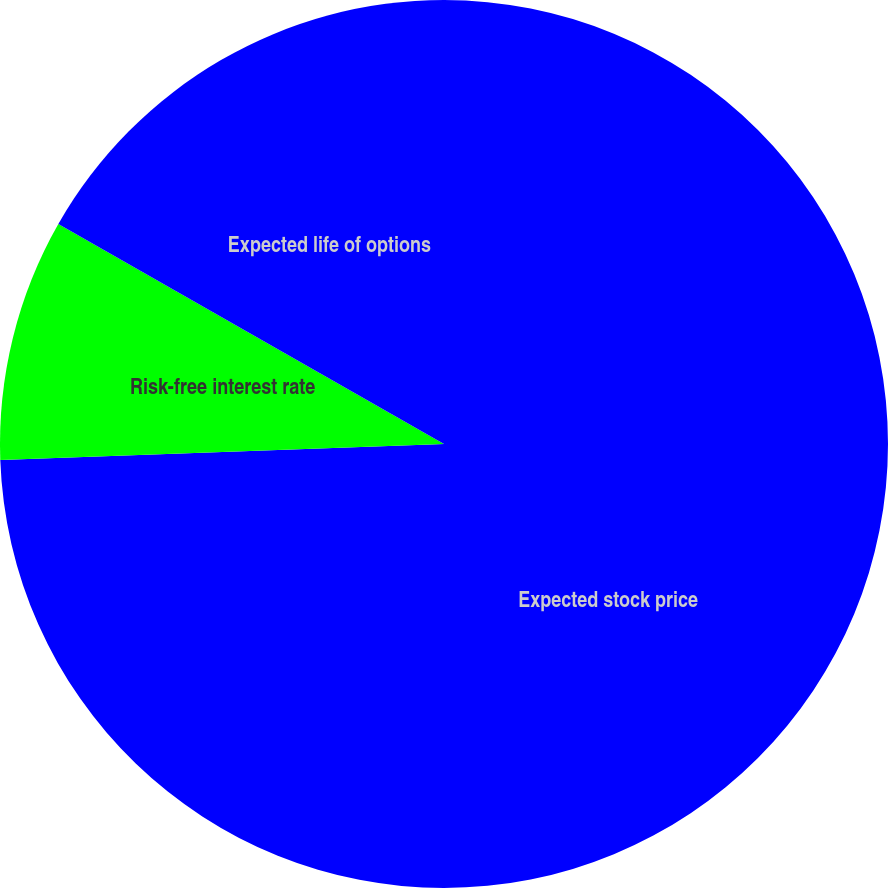Convert chart. <chart><loc_0><loc_0><loc_500><loc_500><pie_chart><fcel>Expected stock price<fcel>Risk-free interest rate<fcel>Expected life of options<nl><fcel>74.43%<fcel>8.82%<fcel>16.75%<nl></chart> 